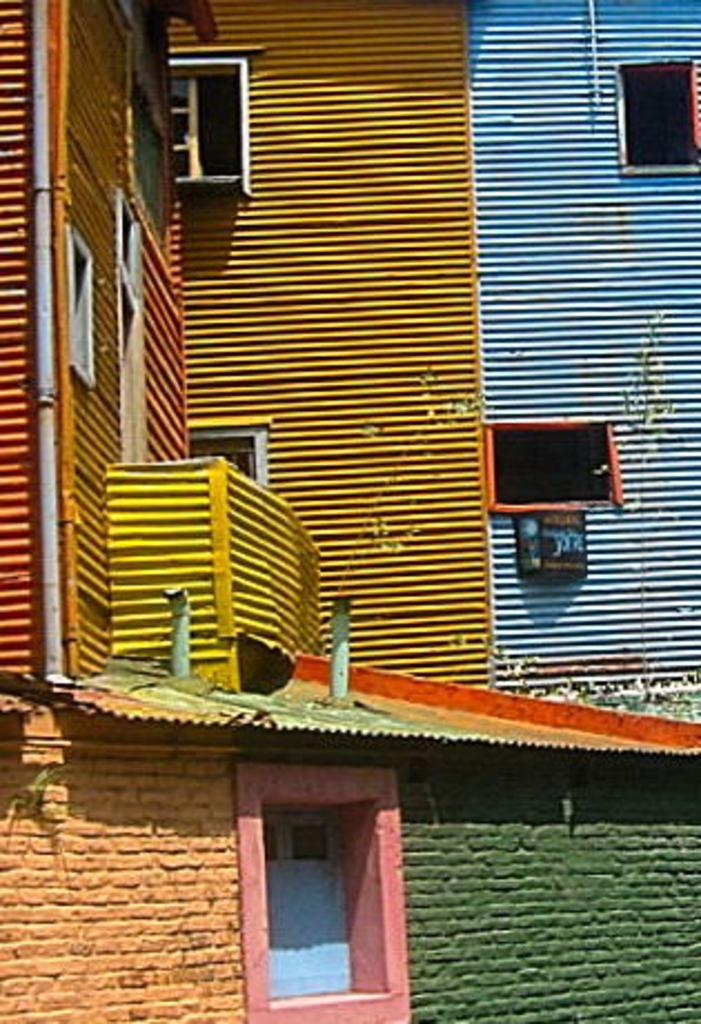What type of structure is present in the image? There is a building in the image. What historical event is depicted in the image involving the mailbox and wealth? There is no historical event, mailbox, or mention of wealth in the image; it only features a building. 